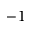Convert formula to latex. <formula><loc_0><loc_0><loc_500><loc_500>- 1</formula> 